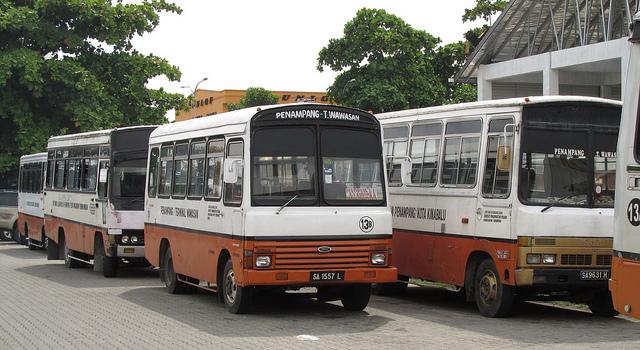How many people are in the photo?
Answer briefly. 0. How many buses?
Write a very short answer. 5. What color are the buses?
Give a very brief answer. White. 